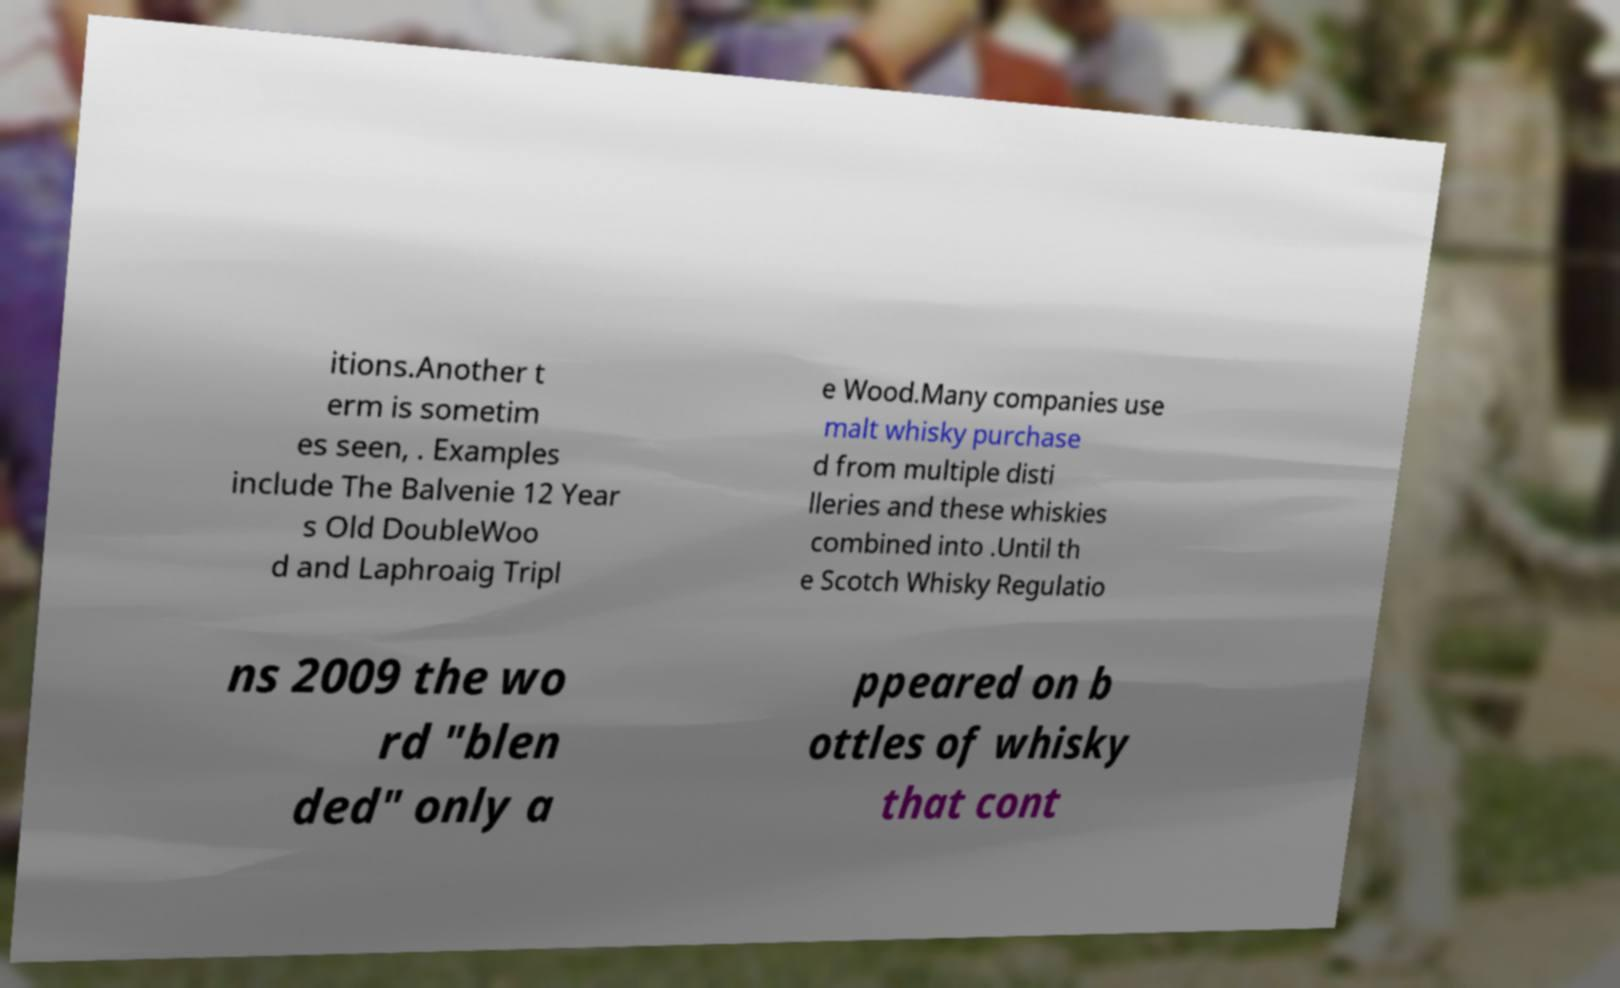I need the written content from this picture converted into text. Can you do that? itions.Another t erm is sometim es seen, . Examples include The Balvenie 12 Year s Old DoubleWoo d and Laphroaig Tripl e Wood.Many companies use malt whisky purchase d from multiple disti lleries and these whiskies combined into .Until th e Scotch Whisky Regulatio ns 2009 the wo rd "blen ded" only a ppeared on b ottles of whisky that cont 